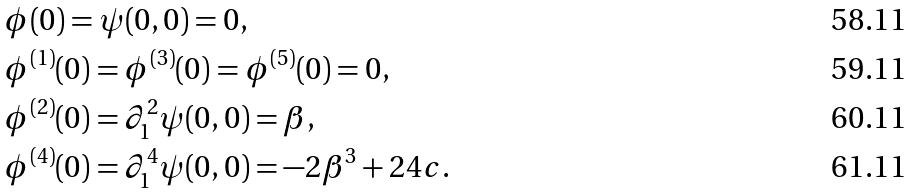<formula> <loc_0><loc_0><loc_500><loc_500>& \phi ( 0 ) = \psi ( 0 , 0 ) = 0 , \\ & \phi ^ { ( 1 ) } ( 0 ) = \phi ^ { ( 3 ) } ( 0 ) = \phi ^ { ( 5 ) } ( 0 ) = 0 , \\ & \phi ^ { ( 2 ) } ( 0 ) = \partial _ { 1 } ^ { 2 } \psi ( 0 , 0 ) = \beta , \\ & \phi ^ { ( 4 ) } ( 0 ) = \partial _ { 1 } ^ { 4 } \psi ( 0 , 0 ) = - 2 \beta ^ { 3 } + 2 4 c .</formula> 